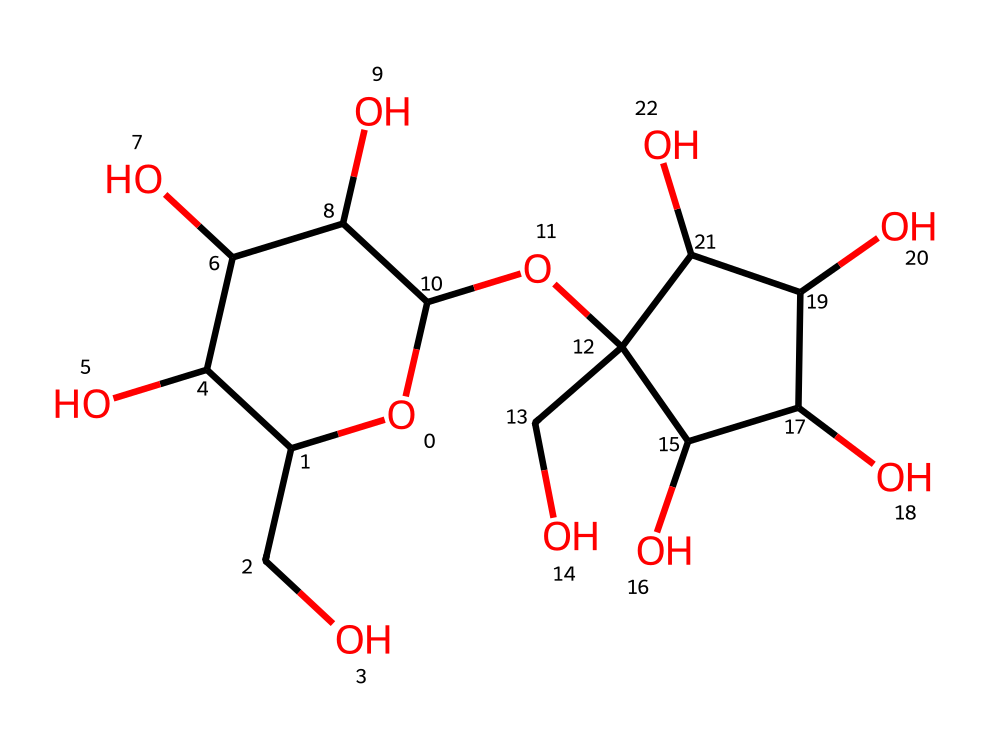What is the molecular formula of this sugar? To derive the molecular formula, we count all the carbon (C), hydrogen (H), and oxygen (O) atoms present in the structure. The molecule shows 12 carbon atoms, 22 hydrogen atoms, and 11 oxygen atoms, leading to the formula C12H22O11.
Answer: C12H22O11 How many ring structures are present in this molecule? Examining the structure, we see that there are two distinct ring structures indicated by the presence of "O1" and "C2". Each of these rings corresponds to a cyclic structure, leading to a total of two rings in the entire molecule.
Answer: 2 What is the primary type of solid this sugar forms? This sugar is classified as a crystalline solid because it demonstrates a well-defined geometric arrangement of its molecules in a lattice structure, typical of sugars that crystallize in pure form.
Answer: crystalline solid How many hydroxyl (–OH) groups are present in this molecule? By identifying the –OH groups in the structure, we can count the number of hydroxyl groups attached to the carbon atoms. The structure reveals that there are 11 hydroxyl groups present, which are key to the molecule's properties.
Answer: 11 What physical property is primarily affected by the crystal lattice structure of this sugar? The crystal lattice structure impacts the solubility of the sugar; a well-ordered crystal lattice often leads to lower solubility in water compared to amorphous forms, which would dissolve more readily.
Answer: solubility What type of intermolecular forces predominantly hold the sugar crystals together? The predominant intermolecular forces in sugar crystals arise from hydrogen bonding, which occurs between the –OH groups of adjacent sugar molecules, providing stability and a solid structure.
Answer: hydrogen bonding 